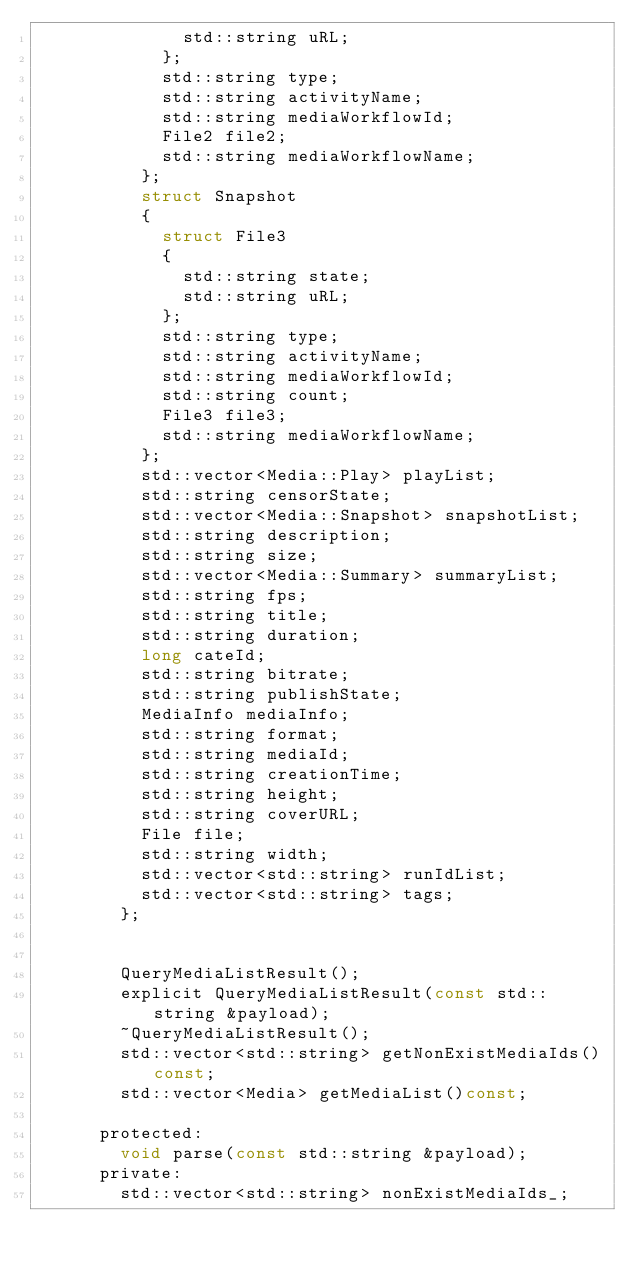<code> <loc_0><loc_0><loc_500><loc_500><_C_>							std::string uRL;
						};
						std::string type;
						std::string activityName;
						std::string mediaWorkflowId;
						File2 file2;
						std::string mediaWorkflowName;
					};
					struct Snapshot
					{
						struct File3
						{
							std::string state;
							std::string uRL;
						};
						std::string type;
						std::string activityName;
						std::string mediaWorkflowId;
						std::string count;
						File3 file3;
						std::string mediaWorkflowName;
					};
					std::vector<Media::Play> playList;
					std::string censorState;
					std::vector<Media::Snapshot> snapshotList;
					std::string description;
					std::string size;
					std::vector<Media::Summary> summaryList;
					std::string fps;
					std::string title;
					std::string duration;
					long cateId;
					std::string bitrate;
					std::string publishState;
					MediaInfo mediaInfo;
					std::string format;
					std::string mediaId;
					std::string creationTime;
					std::string height;
					std::string coverURL;
					File file;
					std::string width;
					std::vector<std::string> runIdList;
					std::vector<std::string> tags;
				};


				QueryMediaListResult();
				explicit QueryMediaListResult(const std::string &payload);
				~QueryMediaListResult();
				std::vector<std::string> getNonExistMediaIds()const;
				std::vector<Media> getMediaList()const;

			protected:
				void parse(const std::string &payload);
			private:
				std::vector<std::string> nonExistMediaIds_;</code> 